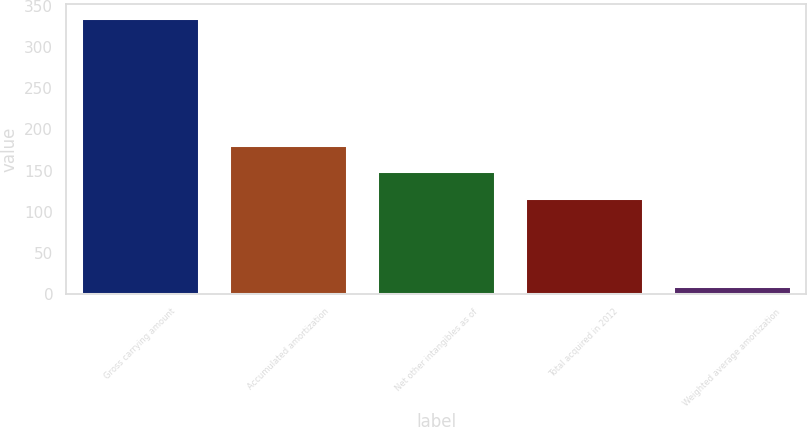<chart> <loc_0><loc_0><loc_500><loc_500><bar_chart><fcel>Gross carrying amount<fcel>Accumulated amortization<fcel>Net other intangibles as of<fcel>Total acquired in 2012<fcel>Weighted average amortization<nl><fcel>335.4<fcel>181.52<fcel>148.96<fcel>116.4<fcel>9.8<nl></chart> 